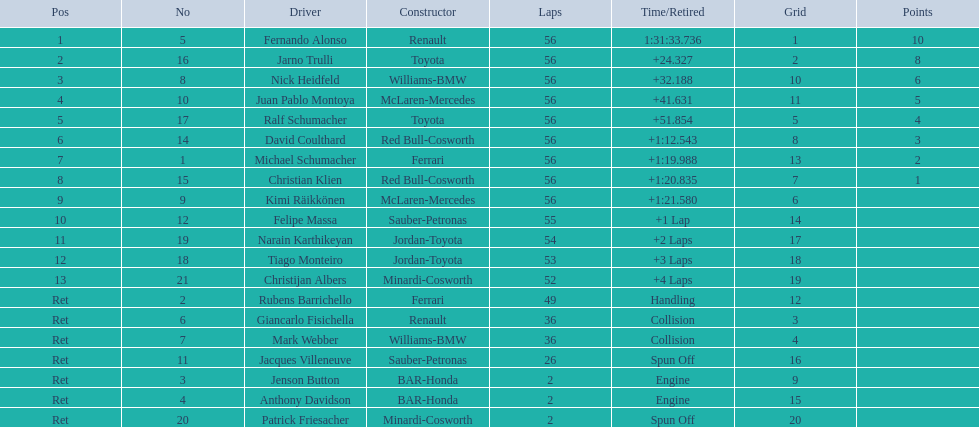Could you help me parse every detail presented in this table? {'header': ['Pos', 'No', 'Driver', 'Constructor', 'Laps', 'Time/Retired', 'Grid', 'Points'], 'rows': [['1', '5', 'Fernando Alonso', 'Renault', '56', '1:31:33.736', '1', '10'], ['2', '16', 'Jarno Trulli', 'Toyota', '56', '+24.327', '2', '8'], ['3', '8', 'Nick Heidfeld', 'Williams-BMW', '56', '+32.188', '10', '6'], ['4', '10', 'Juan Pablo Montoya', 'McLaren-Mercedes', '56', '+41.631', '11', '5'], ['5', '17', 'Ralf Schumacher', 'Toyota', '56', '+51.854', '5', '4'], ['6', '14', 'David Coulthard', 'Red Bull-Cosworth', '56', '+1:12.543', '8', '3'], ['7', '1', 'Michael Schumacher', 'Ferrari', '56', '+1:19.988', '13', '2'], ['8', '15', 'Christian Klien', 'Red Bull-Cosworth', '56', '+1:20.835', '7', '1'], ['9', '9', 'Kimi Räikkönen', 'McLaren-Mercedes', '56', '+1:21.580', '6', ''], ['10', '12', 'Felipe Massa', 'Sauber-Petronas', '55', '+1 Lap', '14', ''], ['11', '19', 'Narain Karthikeyan', 'Jordan-Toyota', '54', '+2 Laps', '17', ''], ['12', '18', 'Tiago Monteiro', 'Jordan-Toyota', '53', '+3 Laps', '18', ''], ['13', '21', 'Christijan Albers', 'Minardi-Cosworth', '52', '+4 Laps', '19', ''], ['Ret', '2', 'Rubens Barrichello', 'Ferrari', '49', 'Handling', '12', ''], ['Ret', '6', 'Giancarlo Fisichella', 'Renault', '36', 'Collision', '3', ''], ['Ret', '7', 'Mark Webber', 'Williams-BMW', '36', 'Collision', '4', ''], ['Ret', '11', 'Jacques Villeneuve', 'Sauber-Petronas', '26', 'Spun Off', '16', ''], ['Ret', '3', 'Jenson Button', 'BAR-Honda', '2', 'Engine', '9', ''], ['Ret', '4', 'Anthony Davidson', 'BAR-Honda', '2', 'Engine', '15', ''], ['Ret', '20', 'Patrick Friesacher', 'Minardi-Cosworth', '2', 'Spun Off', '20', '']]} Jarno trulli wasn't french, so what was his nationality? Italian. 